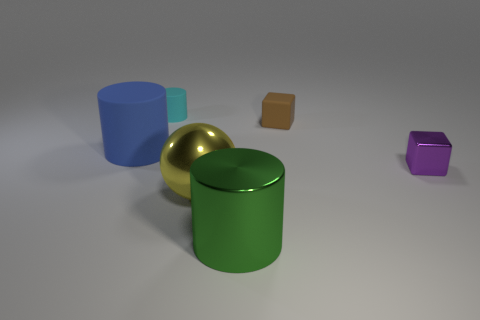There is a cylinder that is right of the large blue matte object and on the left side of the big green object; what material is it?
Offer a very short reply. Rubber. There is a block to the left of the tiny purple shiny block; are there any small things in front of it?
Give a very brief answer. Yes. Is the material of the big blue thing the same as the brown object?
Offer a terse response. Yes. The thing that is behind the large blue cylinder and on the left side of the tiny brown cube has what shape?
Your answer should be very brief. Cylinder. What is the size of the object that is behind the small block that is behind the tiny purple metal block?
Make the answer very short. Small. What number of large yellow metallic objects have the same shape as the tiny purple thing?
Make the answer very short. 0. Is there anything else that has the same shape as the big yellow thing?
Ensure brevity in your answer.  No. Is the cylinder that is behind the tiny brown block made of the same material as the block that is to the right of the brown matte cube?
Your answer should be very brief. No. What color is the tiny metal object?
Offer a terse response. Purple. There is a thing that is to the right of the cube that is on the left side of the shiny thing to the right of the big shiny cylinder; what is its size?
Your answer should be very brief. Small. 